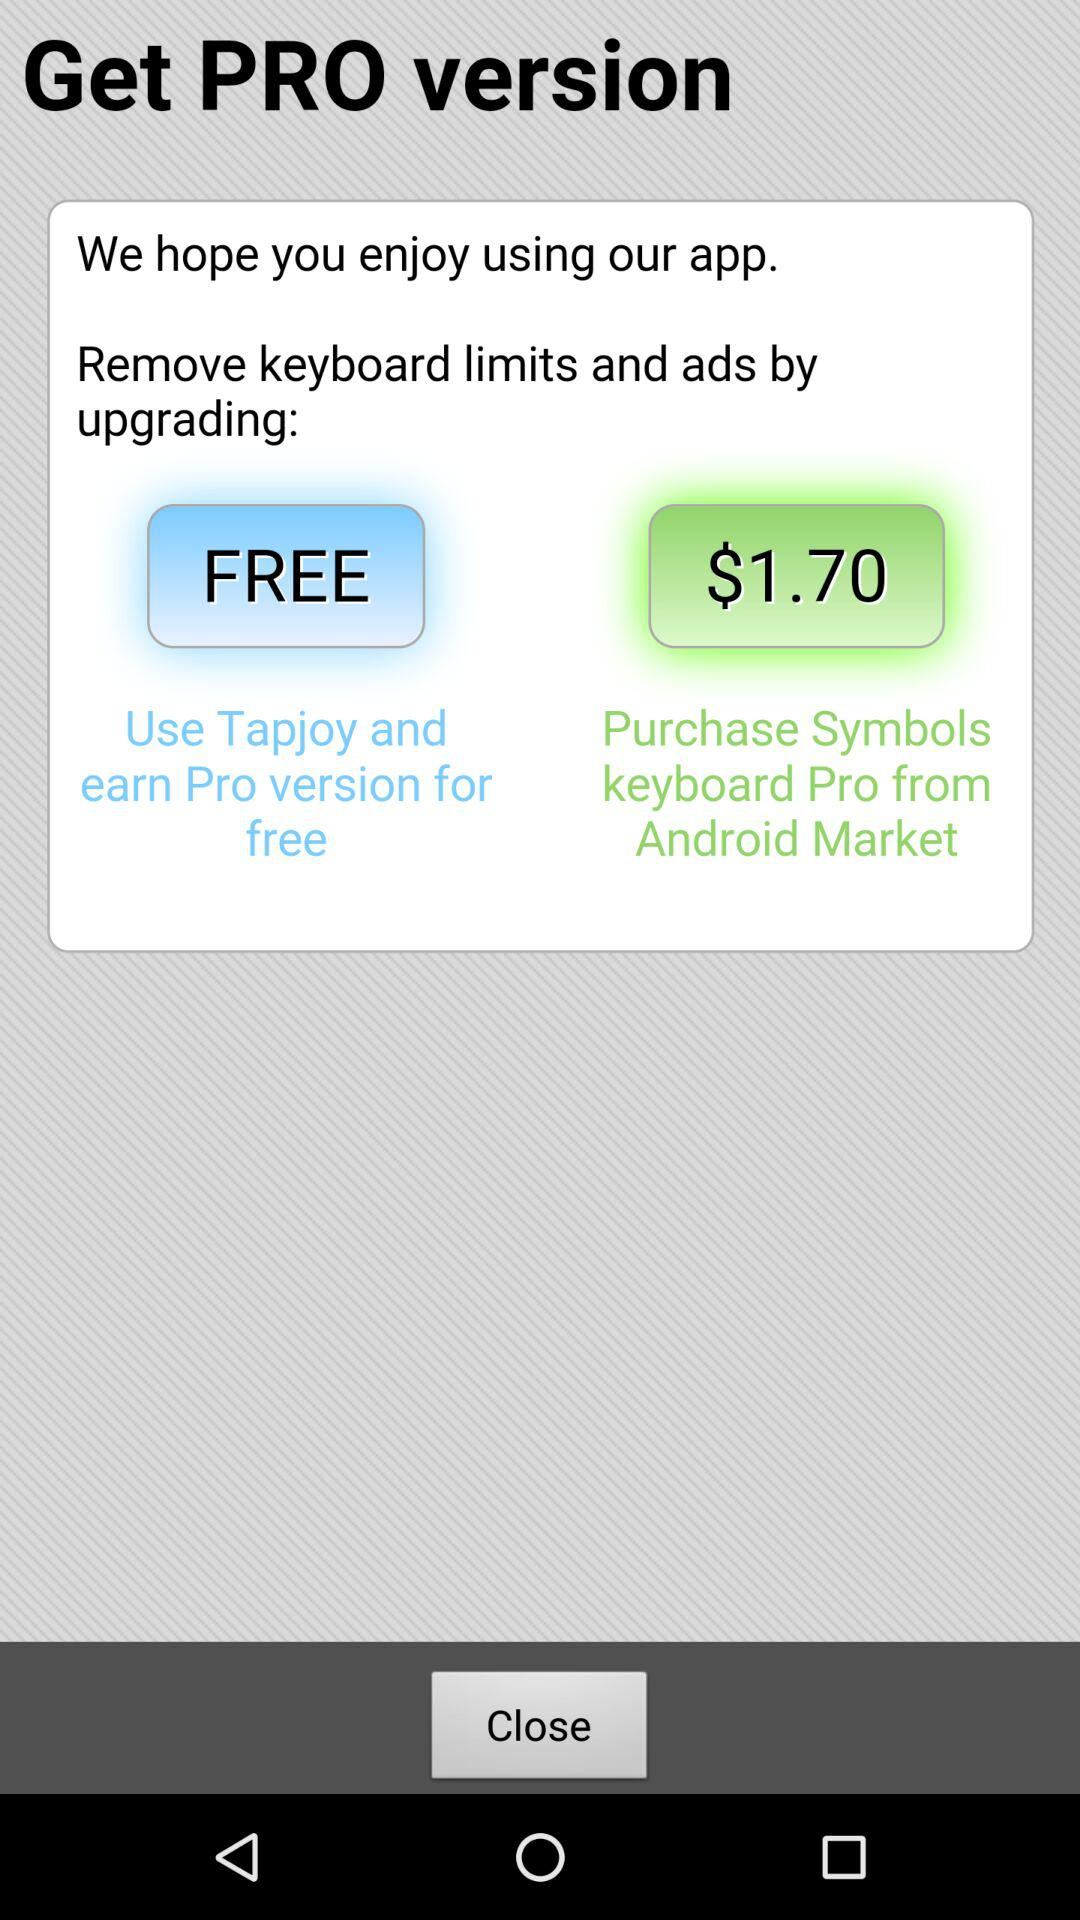How many ways are there to upgrade to the Pro version?
Answer the question using a single word or phrase. 2 